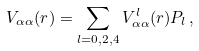Convert formula to latex. <formula><loc_0><loc_0><loc_500><loc_500>V _ { \alpha \alpha } ( r ) = \sum _ { l = 0 , 2 , 4 } V ^ { l } _ { \alpha \alpha } ( r ) P _ { l } \, ,</formula> 